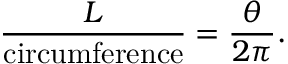<formula> <loc_0><loc_0><loc_500><loc_500>{ \frac { L } { c i r c u m f e r e n c e } } = { \frac { \theta } { 2 \pi } } .</formula> 